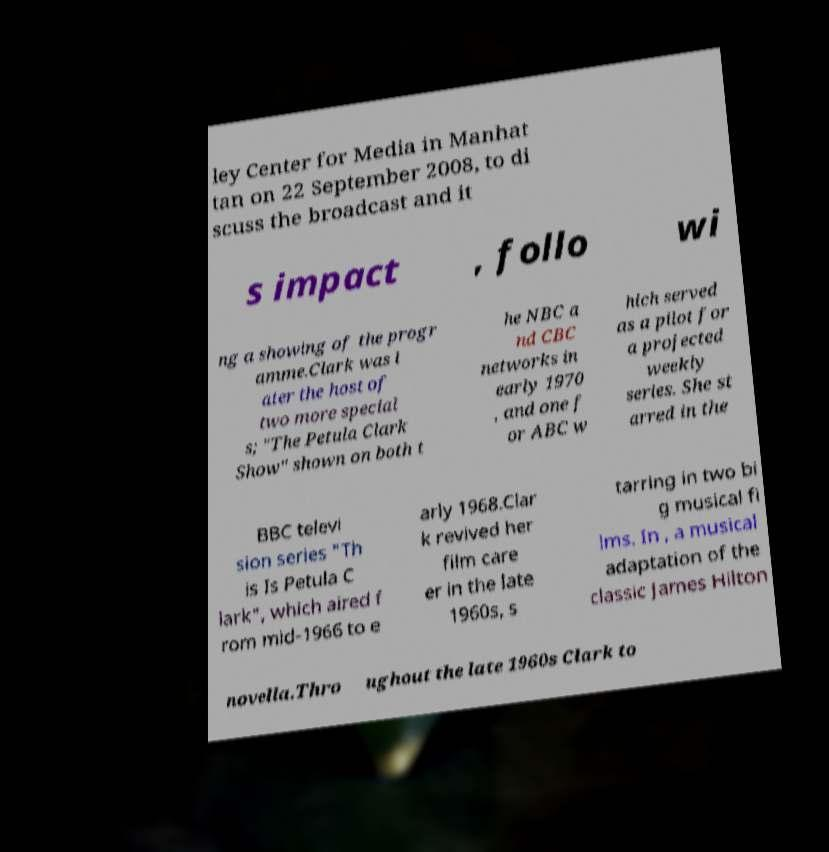Can you accurately transcribe the text from the provided image for me? ley Center for Media in Manhat tan on 22 September 2008, to di scuss the broadcast and it s impact , follo wi ng a showing of the progr amme.Clark was l ater the host of two more special s; "The Petula Clark Show" shown on both t he NBC a nd CBC networks in early 1970 , and one f or ABC w hich served as a pilot for a projected weekly series. She st arred in the BBC televi sion series "Th is Is Petula C lark", which aired f rom mid-1966 to e arly 1968.Clar k revived her film care er in the late 1960s, s tarring in two bi g musical fi lms. In , a musical adaptation of the classic James Hilton novella.Thro ughout the late 1960s Clark to 